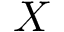Convert formula to latex. <formula><loc_0><loc_0><loc_500><loc_500>X</formula> 